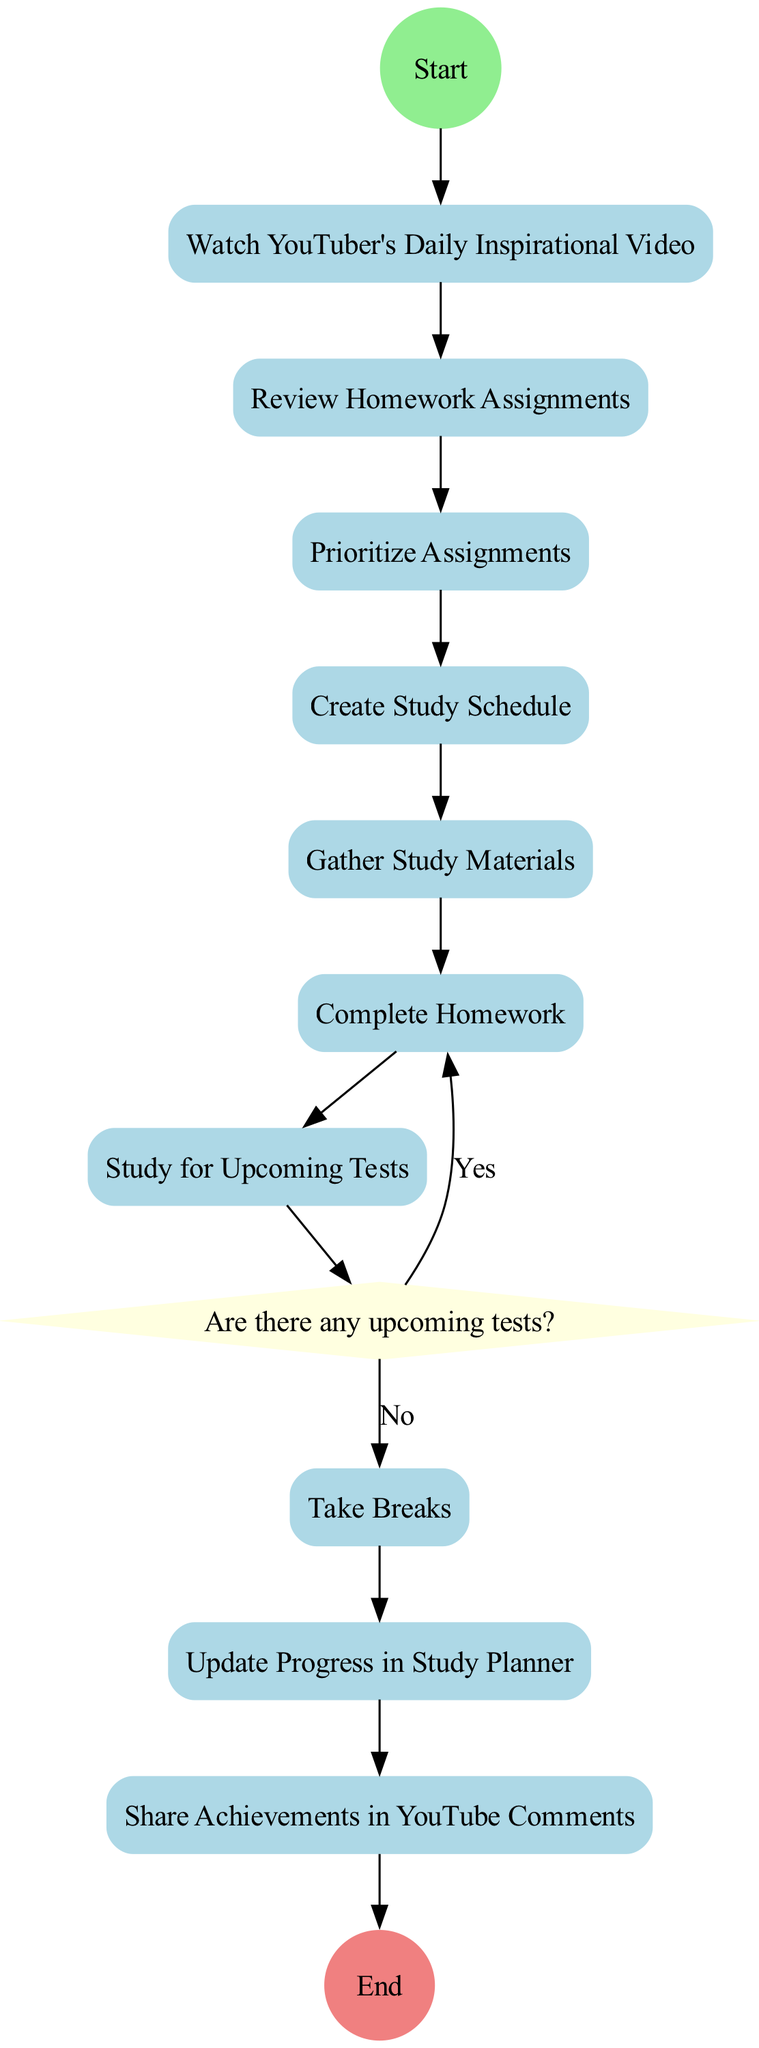What is the first activity in the diagram? The first activity directly connected to the starting point is "Watch YouTuber's Daily Inspirational Video." This is determined by the flow that starts from the 'Start' node.
Answer: Watch YouTuber's Daily Inspirational Video How many activities are listed in the diagram? There are ten activities listed in the diagram as seen in the provided data, which also corresponds to the number of unique nodes representing activities.
Answer: 10 What happens after "Study for Upcoming Tests"? After "Study for Upcoming Tests," the next process is a decision point labeled "Are there any upcoming tests?". The flow leads to a decision that determines the next steps based on whether there are tests or not.
Answer: Decision point If there are no upcoming tests, what is the next activity? If there are no upcoming tests, the next activity after the decision point is "Complete Homework." This is derived directly from the flow leading out of the 'No' branch of the decision point.
Answer: Complete Homework How many decision points are present in the diagram? There is one decision point in the diagram, indicated by the diamond-shaped node that asks "Are there any upcoming tests?"
Answer: 1 What activity comes last before reaching "End"? The last activity before reaching the "End" is "Share Achievements in YouTube Comments," as it is the final node connected directly to the 'End' node in the flow.
Answer: Share Achievements in YouTube Comments Which activity is connected to the decision point by the 'Yes' choice? The activity connected to the decision point labeled 'Yes' is "Study for Upcoming Tests." This is identified by tracing the flow from the decision point back to the previous activity due to the decision being affirmative.
Answer: Study for Upcoming Tests What color is used for the start node? The start node is colored light green, which can be noted from the description given for the 'Start' node in the diagram.
Answer: Light green 